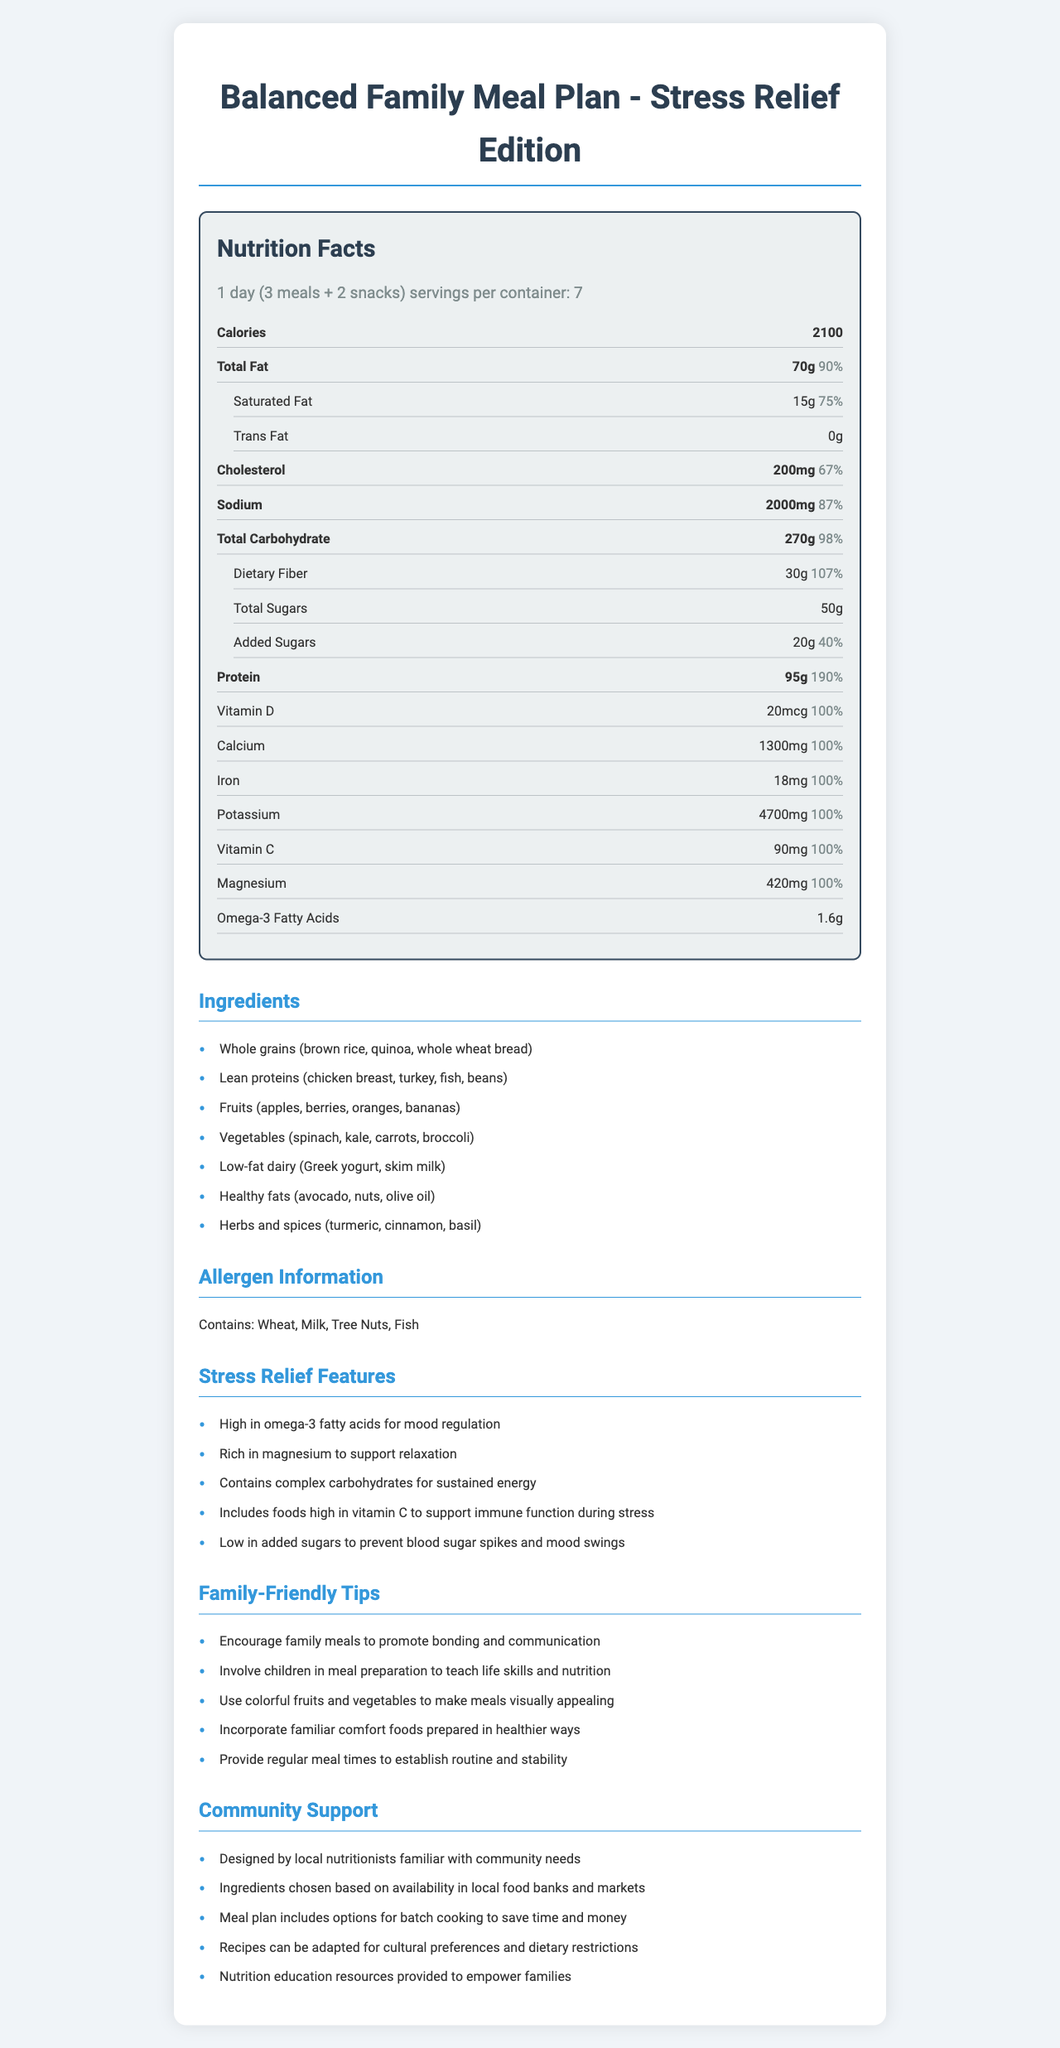what is the serving size for this meal plan? The serving size is indicated in the nutrition label under the section "serving info".
Answer: 1 day (3 meals + 2 snacks) how many calories are there per serving? The calories per serving are listed as 2100 in the bold section at the top of the nutrition facts.
Answer: 2100 what is the total fat content per serving? The total fat content per serving is listed as 70 grams under the "Total Fat" section in the nutrition facts label.
Answer: 70g what percentage of the daily value does the dietary fiber content represent? The daily value percentage for dietary fiber is shown as 107% in the indent section under "Total Carbohydrate".
Answer: 107% name two ingredients listed in the meal plan. A selection of ingredients is given in the "Ingredients" section.
Answer: Whole grains (brown rice, quinoa, whole wheat bread), Lean proteins (chicken breast, turkey, fish, beans) which of the following is a stress relief feature of the meal plan? A. High in Omega-6 fatty acids B. Low in added sugars C. High in saturated fats D. Contains simple carbohydrates B is correct as it matches the stress relief feature "Low in added sugars to prevent blood sugar spikes and mood swings".
Answer: B how much potassium does the meal plan contain per serving? The potassium content per serving is listed as 4700 mg under the "Potassium" section in the nutrition facts label.
Answer: 4700mg is this meal plan suitable for someone with a tree nut allergy? The allergen information states that the meal plan contains tree nuts.
Answer: No summarize the main features of this meal plan. The summary encompasses the key nutritional information, ingredients, stress-relief features, family tips, and community support aspects of the meal plan.
Answer: This is a balanced family meal plan designed for stress relief, providing 2100 calories per serving. It includes ingredients like whole grains, lean proteins, fruits, and vegetables. It is high in omega-3 fatty acids, magnesium, and vitamin C and low in added sugars. The meal plan also focuses on family-friendly tips and community support. how much cholesterol does the meal plan contain? The cholesterol content per serving is listed as 200 mg in the bold category under "Cholesterol".
Answer: 200mg what is the percentage of the daily value for protein provided by this meal plan? The daily value percentage for protein is given as 190% in the bold section under "Protein".
Answer: 190% which minerals are included in this meal plan? A. Magnesium, Zinc, Iron B. Iron, Calcium, Magnesium C. Calcium, Zinc, Potassium D. Potassium, Magnesium, Manganese B is correct as the nutrition label lists iron, calcium, and magnesium under their respective sections.
Answer: B what kind of support does this meal plan offer to the community? (select all that apply) 1. Designed by local nutritionists 2. Imported ingredients 3. Options for batch cooking 4. Recipes for cultural preferences 5. Funding for families The community support section lists local nutritionists, batch cooking options, and adaptable recipes for cultural preferences.
Answer: 1, 3, 4 what is the percentage of daily value for omega-3 fatty acids in the meal plan? The document provides the amount of omega-3 fatty acids (1.6g) but does not specify the daily value percentage for these fatty acids.
Answer: Not enough information does this meal plan include any trans fats? The nutrition facts label indicates that there are 0 grams of trans fat per serving.
Answer: No 